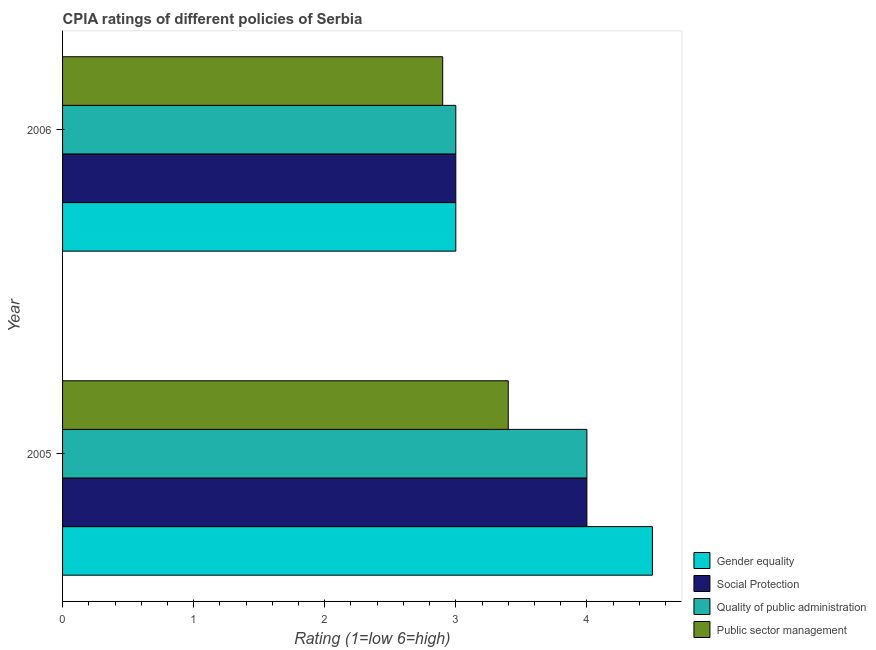How many different coloured bars are there?
Offer a very short reply. 4. How many groups of bars are there?
Ensure brevity in your answer.  2. How many bars are there on the 1st tick from the bottom?
Your answer should be compact. 4. What is the label of the 1st group of bars from the top?
Provide a short and direct response. 2006. Across all years, what is the maximum cpia rating of quality of public administration?
Your answer should be very brief. 4. Across all years, what is the minimum cpia rating of social protection?
Ensure brevity in your answer.  3. In which year was the cpia rating of gender equality minimum?
Make the answer very short. 2006. What is the total cpia rating of social protection in the graph?
Give a very brief answer. 7. What is the difference between the cpia rating of quality of public administration in 2005 and that in 2006?
Keep it short and to the point. 1. What is the difference between the cpia rating of public sector management in 2006 and the cpia rating of quality of public administration in 2005?
Give a very brief answer. -1.1. What is the average cpia rating of public sector management per year?
Offer a terse response. 3.15. In the year 2006, what is the difference between the cpia rating of social protection and cpia rating of gender equality?
Give a very brief answer. 0. In how many years, is the cpia rating of public sector management greater than 1.4 ?
Provide a short and direct response. 2. What is the ratio of the cpia rating of gender equality in 2005 to that in 2006?
Your response must be concise. 1.5. Is the difference between the cpia rating of social protection in 2005 and 2006 greater than the difference between the cpia rating of public sector management in 2005 and 2006?
Your answer should be compact. Yes. In how many years, is the cpia rating of quality of public administration greater than the average cpia rating of quality of public administration taken over all years?
Your answer should be compact. 1. Is it the case that in every year, the sum of the cpia rating of quality of public administration and cpia rating of social protection is greater than the sum of cpia rating of public sector management and cpia rating of gender equality?
Offer a terse response. No. What does the 1st bar from the top in 2005 represents?
Give a very brief answer. Public sector management. What does the 1st bar from the bottom in 2006 represents?
Offer a very short reply. Gender equality. How many years are there in the graph?
Ensure brevity in your answer.  2. Are the values on the major ticks of X-axis written in scientific E-notation?
Offer a very short reply. No. Where does the legend appear in the graph?
Your answer should be compact. Bottom right. What is the title of the graph?
Ensure brevity in your answer.  CPIA ratings of different policies of Serbia. Does "Greece" appear as one of the legend labels in the graph?
Your answer should be very brief. No. What is the label or title of the X-axis?
Your answer should be compact. Rating (1=low 6=high). What is the label or title of the Y-axis?
Offer a terse response. Year. What is the Rating (1=low 6=high) of Gender equality in 2005?
Provide a succinct answer. 4.5. What is the Rating (1=low 6=high) in Quality of public administration in 2005?
Your response must be concise. 4. What is the Rating (1=low 6=high) of Public sector management in 2005?
Provide a succinct answer. 3.4. What is the Rating (1=low 6=high) of Gender equality in 2006?
Your response must be concise. 3. Across all years, what is the maximum Rating (1=low 6=high) of Public sector management?
Give a very brief answer. 3.4. Across all years, what is the minimum Rating (1=low 6=high) in Gender equality?
Offer a very short reply. 3. Across all years, what is the minimum Rating (1=low 6=high) in Public sector management?
Give a very brief answer. 2.9. What is the total Rating (1=low 6=high) in Gender equality in the graph?
Make the answer very short. 7.5. What is the total Rating (1=low 6=high) of Public sector management in the graph?
Offer a very short reply. 6.3. What is the difference between the Rating (1=low 6=high) in Gender equality in 2005 and that in 2006?
Offer a terse response. 1.5. What is the difference between the Rating (1=low 6=high) in Quality of public administration in 2005 and that in 2006?
Your response must be concise. 1. What is the difference between the Rating (1=low 6=high) of Gender equality in 2005 and the Rating (1=low 6=high) of Public sector management in 2006?
Keep it short and to the point. 1.6. What is the difference between the Rating (1=low 6=high) in Social Protection in 2005 and the Rating (1=low 6=high) in Public sector management in 2006?
Your answer should be compact. 1.1. What is the average Rating (1=low 6=high) of Gender equality per year?
Ensure brevity in your answer.  3.75. What is the average Rating (1=low 6=high) in Social Protection per year?
Make the answer very short. 3.5. What is the average Rating (1=low 6=high) of Public sector management per year?
Keep it short and to the point. 3.15. In the year 2005, what is the difference between the Rating (1=low 6=high) in Gender equality and Rating (1=low 6=high) in Social Protection?
Your answer should be very brief. 0.5. In the year 2005, what is the difference between the Rating (1=low 6=high) in Gender equality and Rating (1=low 6=high) in Quality of public administration?
Provide a short and direct response. 0.5. In the year 2005, what is the difference between the Rating (1=low 6=high) in Gender equality and Rating (1=low 6=high) in Public sector management?
Offer a terse response. 1.1. In the year 2005, what is the difference between the Rating (1=low 6=high) of Social Protection and Rating (1=low 6=high) of Public sector management?
Your response must be concise. 0.6. In the year 2006, what is the difference between the Rating (1=low 6=high) in Gender equality and Rating (1=low 6=high) in Quality of public administration?
Your answer should be very brief. 0. In the year 2006, what is the difference between the Rating (1=low 6=high) in Gender equality and Rating (1=low 6=high) in Public sector management?
Your answer should be compact. 0.1. In the year 2006, what is the difference between the Rating (1=low 6=high) in Social Protection and Rating (1=low 6=high) in Quality of public administration?
Your answer should be compact. 0. In the year 2006, what is the difference between the Rating (1=low 6=high) of Quality of public administration and Rating (1=low 6=high) of Public sector management?
Ensure brevity in your answer.  0.1. What is the ratio of the Rating (1=low 6=high) in Gender equality in 2005 to that in 2006?
Offer a terse response. 1.5. What is the ratio of the Rating (1=low 6=high) in Public sector management in 2005 to that in 2006?
Give a very brief answer. 1.17. What is the difference between the highest and the second highest Rating (1=low 6=high) of Quality of public administration?
Provide a short and direct response. 1. What is the difference between the highest and the second highest Rating (1=low 6=high) of Public sector management?
Keep it short and to the point. 0.5. What is the difference between the highest and the lowest Rating (1=low 6=high) in Gender equality?
Ensure brevity in your answer.  1.5. 